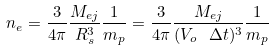<formula> <loc_0><loc_0><loc_500><loc_500>n _ { e } = \frac { 3 } { 4 \pi } \frac { M _ { e j } } { R _ { s } ^ { 3 } } \frac { 1 } { m _ { p } } = \frac { 3 } { 4 \pi } \frac { M _ { e j } } { ( V _ { o } \ \Delta t ) ^ { 3 } } \frac { 1 } { m _ { p } }</formula> 